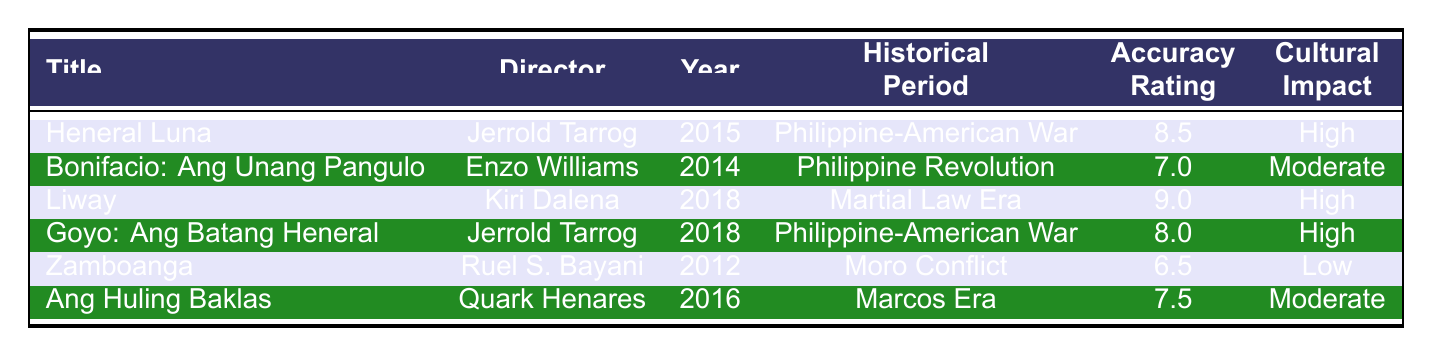What is the title of the film with the highest accuracy rating? The highest accuracy rating is 9.0, which corresponds to the film "Liway."
Answer: Liway Who directed "Heneral Luna"? The table lists Jerrold Tarrog as the director of "Heneral Luna."
Answer: Jerrold Tarrog In which year was "Bonifacio: Ang Unang Pangulo" released? The table indicates that "Bonifacio: Ang Unang Pangulo" was released in 2014.
Answer: 2014 What is the cultural impact rating of the film "Zamboanga"? According to the table, "Zamboanga" has a cultural impact rating described as low.
Answer: Low Which historical period does "Goyo: Ang Batang Heneral" depict? The table states that "Goyo: Ang Batang Heneral" depicts the Philippine-American War.
Answer: Philippine-American War What is the average accuracy rating of the films listed in the table? To find the average, sum the accuracy ratings: (8.5 + 7.0 + 9.0 + 8.0 + 6.5 + 7.5) = 46.5; there are 6 films, so the average is 46.5/6 = 7.75.
Answer: 7.75 What is the total cultural impact rating of all films combined? The cultural impact ratings are "High", "Moderate", "High", "High", "Low", and "Moderate." Using a simple scoring system (High = 2, Moderate = 1, Low = 0): (2 + 1 + 2 + 2 + 0 + 1) = 8.
Answer: 8 Are there any films that have the same director? Yes, both "Heneral Luna" and "Goyo: Ang Batang Heneral" are directed by Jerrold Tarrog.
Answer: Yes Which film features the character Cynthia D. B. Tanyag? The table shows that the film "Liway" features the character Cynthia D. B. Tanyag.
Answer: Liway How many films rated higher than 7.5 were released after 2015? The films released after 2015 with ratings higher than 7.5 are "Liway" (9.0) and "Goyo: Ang Batang Heneral" (8.0), totaling 2 films.
Answer: 2 